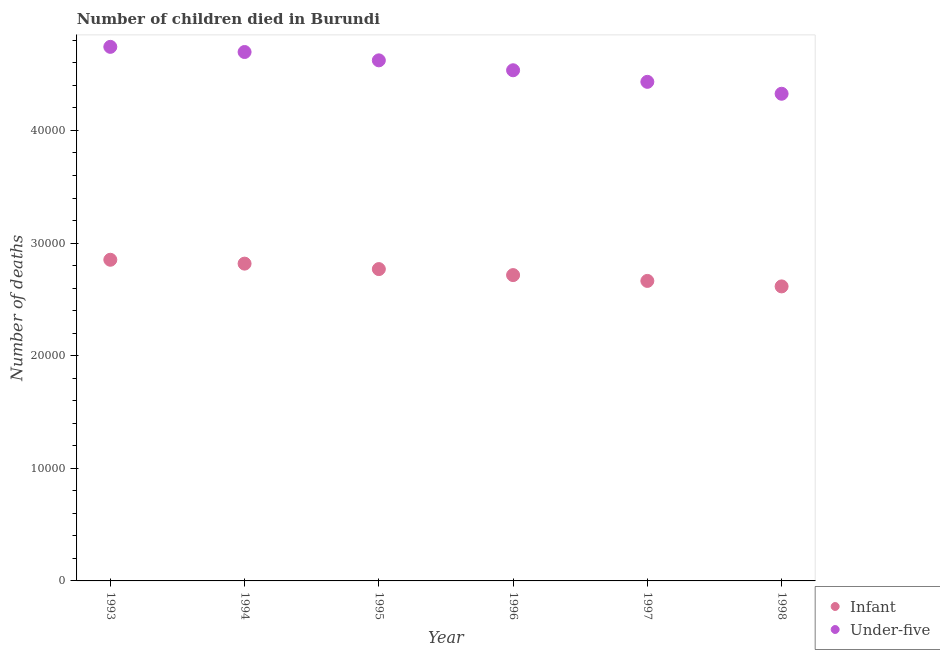How many different coloured dotlines are there?
Offer a very short reply. 2. What is the number of infant deaths in 1994?
Provide a short and direct response. 2.82e+04. Across all years, what is the maximum number of under-five deaths?
Your answer should be very brief. 4.74e+04. Across all years, what is the minimum number of infant deaths?
Your response must be concise. 2.62e+04. In which year was the number of infant deaths maximum?
Make the answer very short. 1993. What is the total number of under-five deaths in the graph?
Provide a succinct answer. 2.74e+05. What is the difference between the number of under-five deaths in 1994 and that in 1997?
Provide a succinct answer. 2650. What is the difference between the number of infant deaths in 1998 and the number of under-five deaths in 1996?
Keep it short and to the point. -1.92e+04. What is the average number of under-five deaths per year?
Give a very brief answer. 4.56e+04. In the year 1993, what is the difference between the number of infant deaths and number of under-five deaths?
Keep it short and to the point. -1.89e+04. What is the ratio of the number of under-five deaths in 1994 to that in 1996?
Give a very brief answer. 1.04. Is the difference between the number of infant deaths in 1993 and 1996 greater than the difference between the number of under-five deaths in 1993 and 1996?
Keep it short and to the point. No. What is the difference between the highest and the second highest number of infant deaths?
Ensure brevity in your answer.  344. What is the difference between the highest and the lowest number of under-five deaths?
Offer a very short reply. 4165. In how many years, is the number of under-five deaths greater than the average number of under-five deaths taken over all years?
Offer a terse response. 3. Is the number of under-five deaths strictly greater than the number of infant deaths over the years?
Offer a very short reply. Yes. Is the number of infant deaths strictly less than the number of under-five deaths over the years?
Provide a succinct answer. Yes. How many years are there in the graph?
Make the answer very short. 6. What is the difference between two consecutive major ticks on the Y-axis?
Provide a short and direct response. 10000. Are the values on the major ticks of Y-axis written in scientific E-notation?
Your answer should be compact. No. Does the graph contain any zero values?
Your response must be concise. No. Does the graph contain grids?
Offer a very short reply. No. Where does the legend appear in the graph?
Provide a short and direct response. Bottom right. How are the legend labels stacked?
Your answer should be very brief. Vertical. What is the title of the graph?
Make the answer very short. Number of children died in Burundi. Does "Time to export" appear as one of the legend labels in the graph?
Offer a very short reply. No. What is the label or title of the X-axis?
Your answer should be compact. Year. What is the label or title of the Y-axis?
Your answer should be very brief. Number of deaths. What is the Number of deaths in Infant in 1993?
Your answer should be very brief. 2.85e+04. What is the Number of deaths of Under-five in 1993?
Offer a terse response. 4.74e+04. What is the Number of deaths of Infant in 1994?
Keep it short and to the point. 2.82e+04. What is the Number of deaths of Under-five in 1994?
Your response must be concise. 4.70e+04. What is the Number of deaths in Infant in 1995?
Your answer should be very brief. 2.77e+04. What is the Number of deaths of Under-five in 1995?
Provide a short and direct response. 4.62e+04. What is the Number of deaths in Infant in 1996?
Make the answer very short. 2.72e+04. What is the Number of deaths of Under-five in 1996?
Your answer should be very brief. 4.53e+04. What is the Number of deaths of Infant in 1997?
Offer a very short reply. 2.66e+04. What is the Number of deaths of Under-five in 1997?
Provide a short and direct response. 4.43e+04. What is the Number of deaths of Infant in 1998?
Your answer should be compact. 2.62e+04. What is the Number of deaths in Under-five in 1998?
Make the answer very short. 4.33e+04. Across all years, what is the maximum Number of deaths of Infant?
Your answer should be very brief. 2.85e+04. Across all years, what is the maximum Number of deaths of Under-five?
Ensure brevity in your answer.  4.74e+04. Across all years, what is the minimum Number of deaths in Infant?
Ensure brevity in your answer.  2.62e+04. Across all years, what is the minimum Number of deaths in Under-five?
Your answer should be very brief. 4.33e+04. What is the total Number of deaths in Infant in the graph?
Ensure brevity in your answer.  1.64e+05. What is the total Number of deaths of Under-five in the graph?
Provide a succinct answer. 2.74e+05. What is the difference between the Number of deaths in Infant in 1993 and that in 1994?
Give a very brief answer. 344. What is the difference between the Number of deaths in Under-five in 1993 and that in 1994?
Offer a very short reply. 458. What is the difference between the Number of deaths of Infant in 1993 and that in 1995?
Offer a terse response. 829. What is the difference between the Number of deaths of Under-five in 1993 and that in 1995?
Make the answer very short. 1199. What is the difference between the Number of deaths in Infant in 1993 and that in 1996?
Give a very brief answer. 1362. What is the difference between the Number of deaths in Under-five in 1993 and that in 1996?
Your answer should be very brief. 2079. What is the difference between the Number of deaths in Infant in 1993 and that in 1997?
Give a very brief answer. 1879. What is the difference between the Number of deaths of Under-five in 1993 and that in 1997?
Offer a terse response. 3108. What is the difference between the Number of deaths in Infant in 1993 and that in 1998?
Your response must be concise. 2366. What is the difference between the Number of deaths in Under-five in 1993 and that in 1998?
Give a very brief answer. 4165. What is the difference between the Number of deaths of Infant in 1994 and that in 1995?
Your answer should be very brief. 485. What is the difference between the Number of deaths of Under-five in 1994 and that in 1995?
Your answer should be compact. 741. What is the difference between the Number of deaths in Infant in 1994 and that in 1996?
Offer a terse response. 1018. What is the difference between the Number of deaths of Under-five in 1994 and that in 1996?
Make the answer very short. 1621. What is the difference between the Number of deaths of Infant in 1994 and that in 1997?
Offer a very short reply. 1535. What is the difference between the Number of deaths of Under-five in 1994 and that in 1997?
Ensure brevity in your answer.  2650. What is the difference between the Number of deaths in Infant in 1994 and that in 1998?
Give a very brief answer. 2022. What is the difference between the Number of deaths of Under-five in 1994 and that in 1998?
Your answer should be compact. 3707. What is the difference between the Number of deaths of Infant in 1995 and that in 1996?
Your answer should be very brief. 533. What is the difference between the Number of deaths of Under-five in 1995 and that in 1996?
Make the answer very short. 880. What is the difference between the Number of deaths in Infant in 1995 and that in 1997?
Make the answer very short. 1050. What is the difference between the Number of deaths in Under-five in 1995 and that in 1997?
Offer a very short reply. 1909. What is the difference between the Number of deaths in Infant in 1995 and that in 1998?
Provide a short and direct response. 1537. What is the difference between the Number of deaths in Under-five in 1995 and that in 1998?
Your response must be concise. 2966. What is the difference between the Number of deaths of Infant in 1996 and that in 1997?
Your answer should be compact. 517. What is the difference between the Number of deaths in Under-five in 1996 and that in 1997?
Offer a terse response. 1029. What is the difference between the Number of deaths in Infant in 1996 and that in 1998?
Offer a very short reply. 1004. What is the difference between the Number of deaths of Under-five in 1996 and that in 1998?
Offer a very short reply. 2086. What is the difference between the Number of deaths in Infant in 1997 and that in 1998?
Your answer should be very brief. 487. What is the difference between the Number of deaths of Under-five in 1997 and that in 1998?
Offer a terse response. 1057. What is the difference between the Number of deaths of Infant in 1993 and the Number of deaths of Under-five in 1994?
Keep it short and to the point. -1.84e+04. What is the difference between the Number of deaths of Infant in 1993 and the Number of deaths of Under-five in 1995?
Make the answer very short. -1.77e+04. What is the difference between the Number of deaths in Infant in 1993 and the Number of deaths in Under-five in 1996?
Your answer should be compact. -1.68e+04. What is the difference between the Number of deaths of Infant in 1993 and the Number of deaths of Under-five in 1997?
Your response must be concise. -1.58e+04. What is the difference between the Number of deaths in Infant in 1993 and the Number of deaths in Under-five in 1998?
Ensure brevity in your answer.  -1.47e+04. What is the difference between the Number of deaths of Infant in 1994 and the Number of deaths of Under-five in 1995?
Make the answer very short. -1.80e+04. What is the difference between the Number of deaths of Infant in 1994 and the Number of deaths of Under-five in 1996?
Ensure brevity in your answer.  -1.72e+04. What is the difference between the Number of deaths of Infant in 1994 and the Number of deaths of Under-five in 1997?
Provide a succinct answer. -1.61e+04. What is the difference between the Number of deaths in Infant in 1994 and the Number of deaths in Under-five in 1998?
Provide a succinct answer. -1.51e+04. What is the difference between the Number of deaths in Infant in 1995 and the Number of deaths in Under-five in 1996?
Ensure brevity in your answer.  -1.77e+04. What is the difference between the Number of deaths in Infant in 1995 and the Number of deaths in Under-five in 1997?
Give a very brief answer. -1.66e+04. What is the difference between the Number of deaths of Infant in 1995 and the Number of deaths of Under-five in 1998?
Keep it short and to the point. -1.56e+04. What is the difference between the Number of deaths of Infant in 1996 and the Number of deaths of Under-five in 1997?
Provide a succinct answer. -1.72e+04. What is the difference between the Number of deaths in Infant in 1996 and the Number of deaths in Under-five in 1998?
Provide a succinct answer. -1.61e+04. What is the difference between the Number of deaths of Infant in 1997 and the Number of deaths of Under-five in 1998?
Provide a succinct answer. -1.66e+04. What is the average Number of deaths of Infant per year?
Provide a succinct answer. 2.74e+04. What is the average Number of deaths in Under-five per year?
Provide a succinct answer. 4.56e+04. In the year 1993, what is the difference between the Number of deaths in Infant and Number of deaths in Under-five?
Your answer should be very brief. -1.89e+04. In the year 1994, what is the difference between the Number of deaths of Infant and Number of deaths of Under-five?
Your response must be concise. -1.88e+04. In the year 1995, what is the difference between the Number of deaths of Infant and Number of deaths of Under-five?
Offer a very short reply. -1.85e+04. In the year 1996, what is the difference between the Number of deaths in Infant and Number of deaths in Under-five?
Your response must be concise. -1.82e+04. In the year 1997, what is the difference between the Number of deaths in Infant and Number of deaths in Under-five?
Make the answer very short. -1.77e+04. In the year 1998, what is the difference between the Number of deaths in Infant and Number of deaths in Under-five?
Give a very brief answer. -1.71e+04. What is the ratio of the Number of deaths in Infant in 1993 to that in 1994?
Your answer should be compact. 1.01. What is the ratio of the Number of deaths in Under-five in 1993 to that in 1994?
Offer a very short reply. 1.01. What is the ratio of the Number of deaths in Infant in 1993 to that in 1995?
Your answer should be compact. 1.03. What is the ratio of the Number of deaths of Under-five in 1993 to that in 1995?
Give a very brief answer. 1.03. What is the ratio of the Number of deaths of Infant in 1993 to that in 1996?
Ensure brevity in your answer.  1.05. What is the ratio of the Number of deaths in Under-five in 1993 to that in 1996?
Offer a very short reply. 1.05. What is the ratio of the Number of deaths of Infant in 1993 to that in 1997?
Make the answer very short. 1.07. What is the ratio of the Number of deaths of Under-five in 1993 to that in 1997?
Provide a short and direct response. 1.07. What is the ratio of the Number of deaths of Infant in 1993 to that in 1998?
Provide a succinct answer. 1.09. What is the ratio of the Number of deaths in Under-five in 1993 to that in 1998?
Provide a succinct answer. 1.1. What is the ratio of the Number of deaths in Infant in 1994 to that in 1995?
Offer a terse response. 1.02. What is the ratio of the Number of deaths of Under-five in 1994 to that in 1995?
Offer a very short reply. 1.02. What is the ratio of the Number of deaths in Infant in 1994 to that in 1996?
Your response must be concise. 1.04. What is the ratio of the Number of deaths in Under-five in 1994 to that in 1996?
Provide a short and direct response. 1.04. What is the ratio of the Number of deaths of Infant in 1994 to that in 1997?
Ensure brevity in your answer.  1.06. What is the ratio of the Number of deaths in Under-five in 1994 to that in 1997?
Offer a terse response. 1.06. What is the ratio of the Number of deaths in Infant in 1994 to that in 1998?
Your answer should be compact. 1.08. What is the ratio of the Number of deaths in Under-five in 1994 to that in 1998?
Ensure brevity in your answer.  1.09. What is the ratio of the Number of deaths of Infant in 1995 to that in 1996?
Your response must be concise. 1.02. What is the ratio of the Number of deaths in Under-five in 1995 to that in 1996?
Give a very brief answer. 1.02. What is the ratio of the Number of deaths in Infant in 1995 to that in 1997?
Make the answer very short. 1.04. What is the ratio of the Number of deaths in Under-five in 1995 to that in 1997?
Offer a very short reply. 1.04. What is the ratio of the Number of deaths of Infant in 1995 to that in 1998?
Provide a succinct answer. 1.06. What is the ratio of the Number of deaths of Under-five in 1995 to that in 1998?
Your answer should be compact. 1.07. What is the ratio of the Number of deaths of Infant in 1996 to that in 1997?
Offer a very short reply. 1.02. What is the ratio of the Number of deaths of Under-five in 1996 to that in 1997?
Provide a succinct answer. 1.02. What is the ratio of the Number of deaths of Infant in 1996 to that in 1998?
Ensure brevity in your answer.  1.04. What is the ratio of the Number of deaths of Under-five in 1996 to that in 1998?
Your answer should be compact. 1.05. What is the ratio of the Number of deaths of Infant in 1997 to that in 1998?
Make the answer very short. 1.02. What is the ratio of the Number of deaths of Under-five in 1997 to that in 1998?
Make the answer very short. 1.02. What is the difference between the highest and the second highest Number of deaths of Infant?
Your answer should be compact. 344. What is the difference between the highest and the second highest Number of deaths in Under-five?
Offer a very short reply. 458. What is the difference between the highest and the lowest Number of deaths of Infant?
Your answer should be compact. 2366. What is the difference between the highest and the lowest Number of deaths of Under-five?
Keep it short and to the point. 4165. 